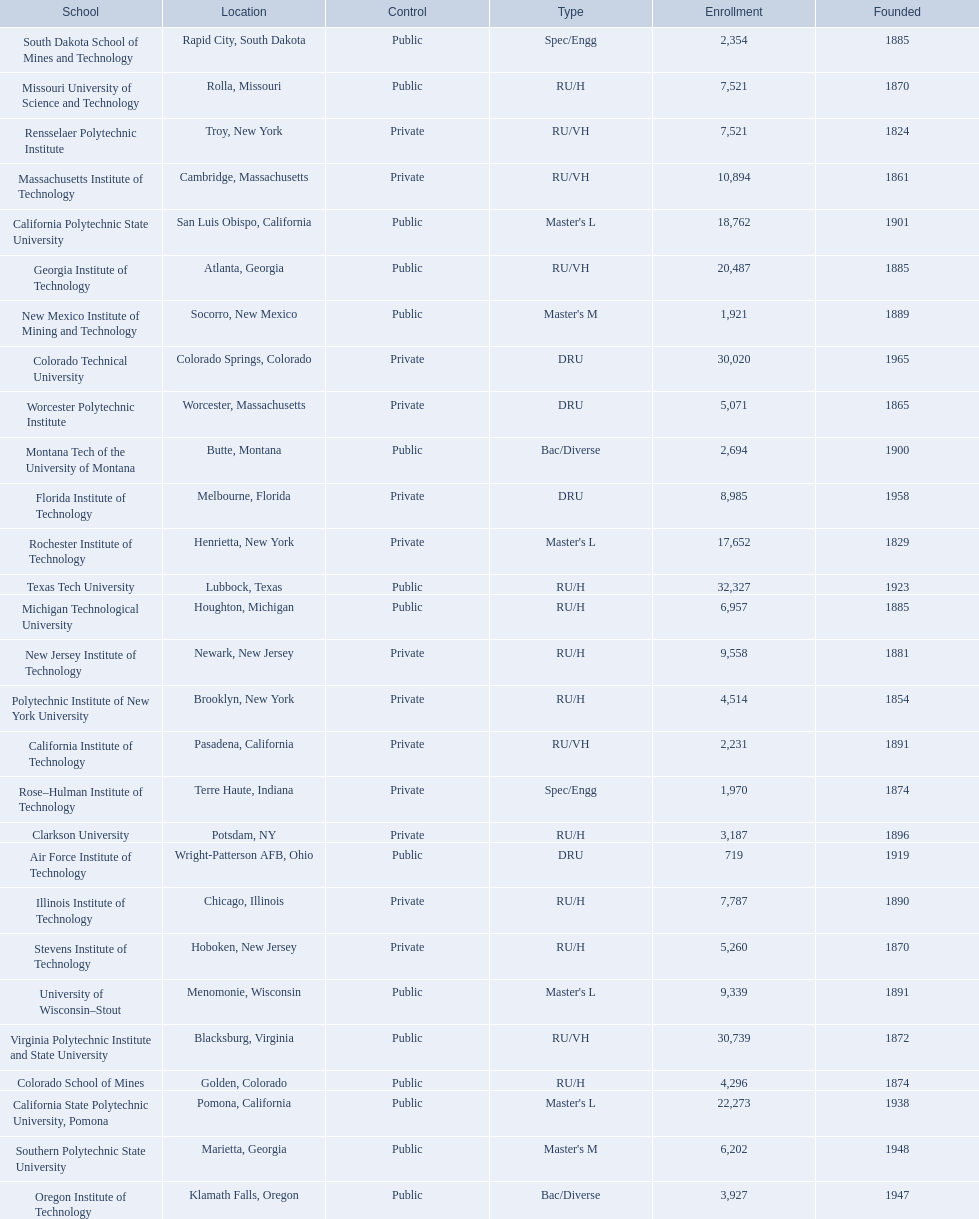What technical universities are in the united states? Air Force Institute of Technology, California Institute of Technology, California Polytechnic State University, California State Polytechnic University, Pomona, Clarkson University, Colorado School of Mines, Colorado Technical University, Florida Institute of Technology, Georgia Institute of Technology, Illinois Institute of Technology, Massachusetts Institute of Technology, Michigan Technological University, Missouri University of Science and Technology, Montana Tech of the University of Montana, New Jersey Institute of Technology, New Mexico Institute of Mining and Technology, Oregon Institute of Technology, Polytechnic Institute of New York University, Rensselaer Polytechnic Institute, Rochester Institute of Technology, Rose–Hulman Institute of Technology, South Dakota School of Mines and Technology, Southern Polytechnic State University, Stevens Institute of Technology, Texas Tech University, University of Wisconsin–Stout, Virginia Polytechnic Institute and State University, Worcester Polytechnic Institute. Which has the highest enrollment? Texas Tech University. 